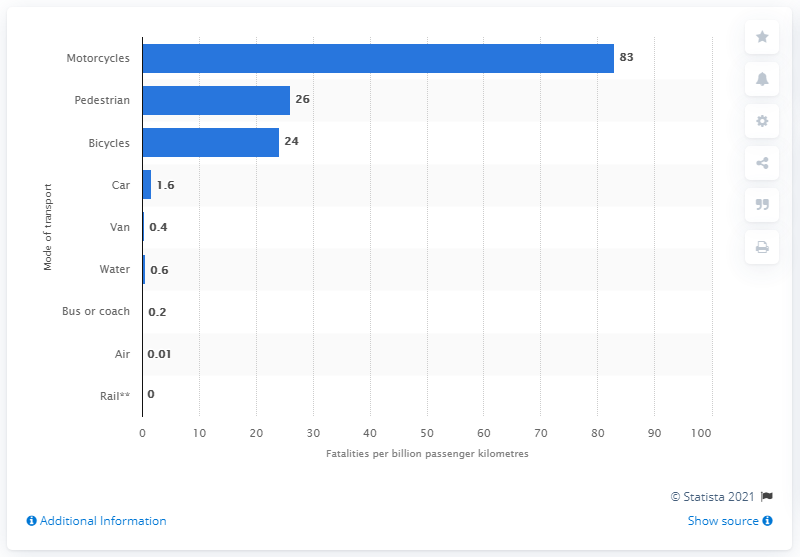Specify some key components in this picture. According to data in Great Britain, the second most fatal mode of transport was... The most fatal transport mode in Great Britain is motorcycles. 